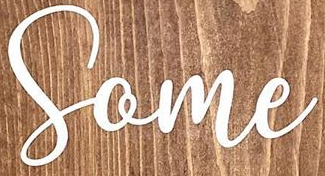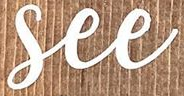What text is displayed in these images sequentially, separated by a semicolon? Some; See 